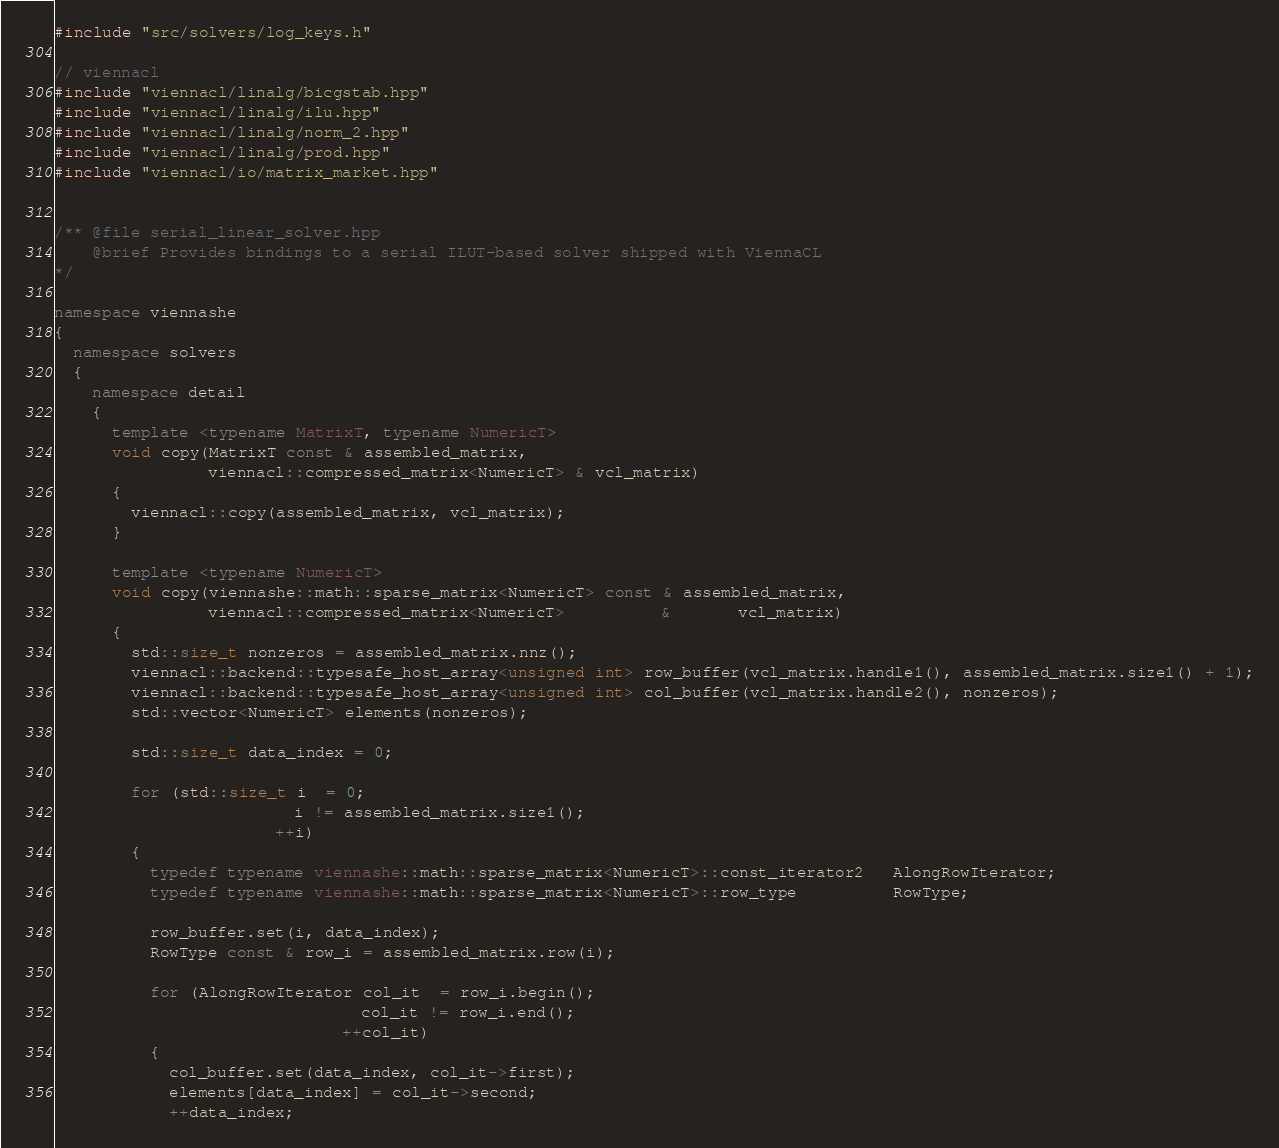<code> <loc_0><loc_0><loc_500><loc_500><_C++_>#include "src/solvers/log_keys.h"

// viennacl
#include "viennacl/linalg/bicgstab.hpp"
#include "viennacl/linalg/ilu.hpp"
#include "viennacl/linalg/norm_2.hpp"
#include "viennacl/linalg/prod.hpp"
#include "viennacl/io/matrix_market.hpp"


/** @file serial_linear_solver.hpp
    @brief Provides bindings to a serial ILUT-based solver shipped with ViennaCL
*/

namespace viennashe
{
  namespace solvers
  {
    namespace detail
    {
      template <typename MatrixT, typename NumericT>
      void copy(MatrixT const & assembled_matrix,
                viennacl::compressed_matrix<NumericT> & vcl_matrix)
      {
        viennacl::copy(assembled_matrix, vcl_matrix);
      }

      template <typename NumericT>
      void copy(viennashe::math::sparse_matrix<NumericT> const & assembled_matrix,
                viennacl::compressed_matrix<NumericT>          &       vcl_matrix)
      {
        std::size_t nonzeros = assembled_matrix.nnz();
        viennacl::backend::typesafe_host_array<unsigned int> row_buffer(vcl_matrix.handle1(), assembled_matrix.size1() + 1);
        viennacl::backend::typesafe_host_array<unsigned int> col_buffer(vcl_matrix.handle2(), nonzeros);
        std::vector<NumericT> elements(nonzeros);

        std::size_t data_index = 0;

        for (std::size_t i  = 0;
                         i != assembled_matrix.size1();
                       ++i)
        {
          typedef typename viennashe::math::sparse_matrix<NumericT>::const_iterator2   AlongRowIterator;
          typedef typename viennashe::math::sparse_matrix<NumericT>::row_type          RowType;

          row_buffer.set(i, data_index);
          RowType const & row_i = assembled_matrix.row(i);

          for (AlongRowIterator col_it  = row_i.begin();
                                col_it != row_i.end();
                              ++col_it)
          {
            col_buffer.set(data_index, col_it->first);
            elements[data_index] = col_it->second;
            ++data_index;</code> 